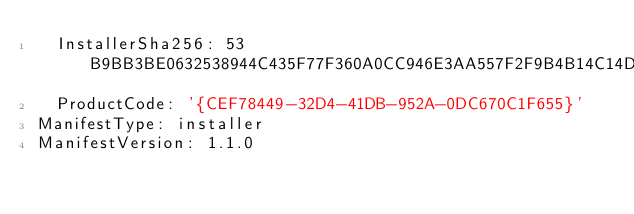Convert code to text. <code><loc_0><loc_0><loc_500><loc_500><_YAML_>  InstallerSha256: 53B9BB3BE0632538944C435F77F360A0CC946E3AA557F2F9B4B14C14D95C3FFE
  ProductCode: '{CEF78449-32D4-41DB-952A-0DC670C1F655}'
ManifestType: installer
ManifestVersion: 1.1.0
</code> 